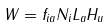Convert formula to latex. <formula><loc_0><loc_0><loc_500><loc_500>W = f _ { i a } N _ { i } L _ { a } H _ { u }</formula> 